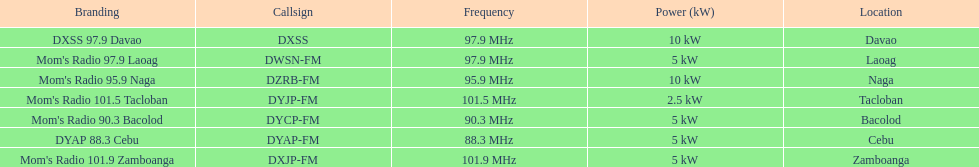How many kw was the radio in davao? 10 kW. 